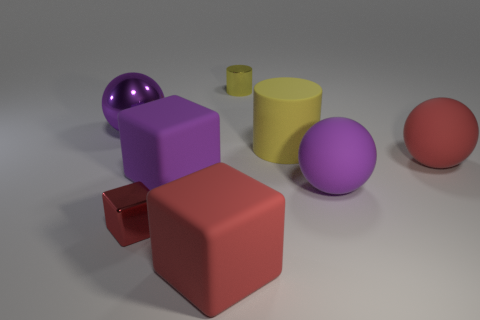There is a small thing that is the same color as the big cylinder; what shape is it?
Provide a short and direct response. Cylinder. What is the thing that is behind the large yellow matte object and in front of the metallic cylinder made of?
Your answer should be compact. Metal. Are there fewer purple cubes that are to the right of the large yellow matte cylinder than big things that are behind the metal cylinder?
Ensure brevity in your answer.  No. What size is the purple object that is the same material as the tiny yellow cylinder?
Offer a terse response. Large. Is there anything else that is the same color as the small metal cube?
Make the answer very short. Yes. Do the tiny yellow cylinder and the red block that is right of the tiny red shiny cube have the same material?
Ensure brevity in your answer.  No. There is a large yellow thing that is the same shape as the small yellow thing; what is its material?
Make the answer very short. Rubber. Is the large red object left of the red ball made of the same material as the yellow object left of the large cylinder?
Provide a short and direct response. No. What is the color of the rubber ball in front of the big red rubber thing that is to the right of the small metal thing behind the big yellow object?
Your answer should be very brief. Purple. What number of other things are there of the same shape as the yellow rubber object?
Keep it short and to the point. 1. 